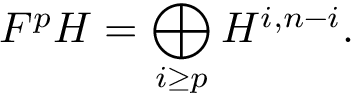Convert formula to latex. <formula><loc_0><loc_0><loc_500><loc_500>F ^ { p } H = \bigoplus _ { i \geq p } H ^ { i , n - i } .</formula> 